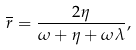<formula> <loc_0><loc_0><loc_500><loc_500>\overline { r } = \frac { 2 \eta } { \omega + \eta + \omega \lambda } ,</formula> 